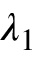Convert formula to latex. <formula><loc_0><loc_0><loc_500><loc_500>\lambda _ { 1 }</formula> 